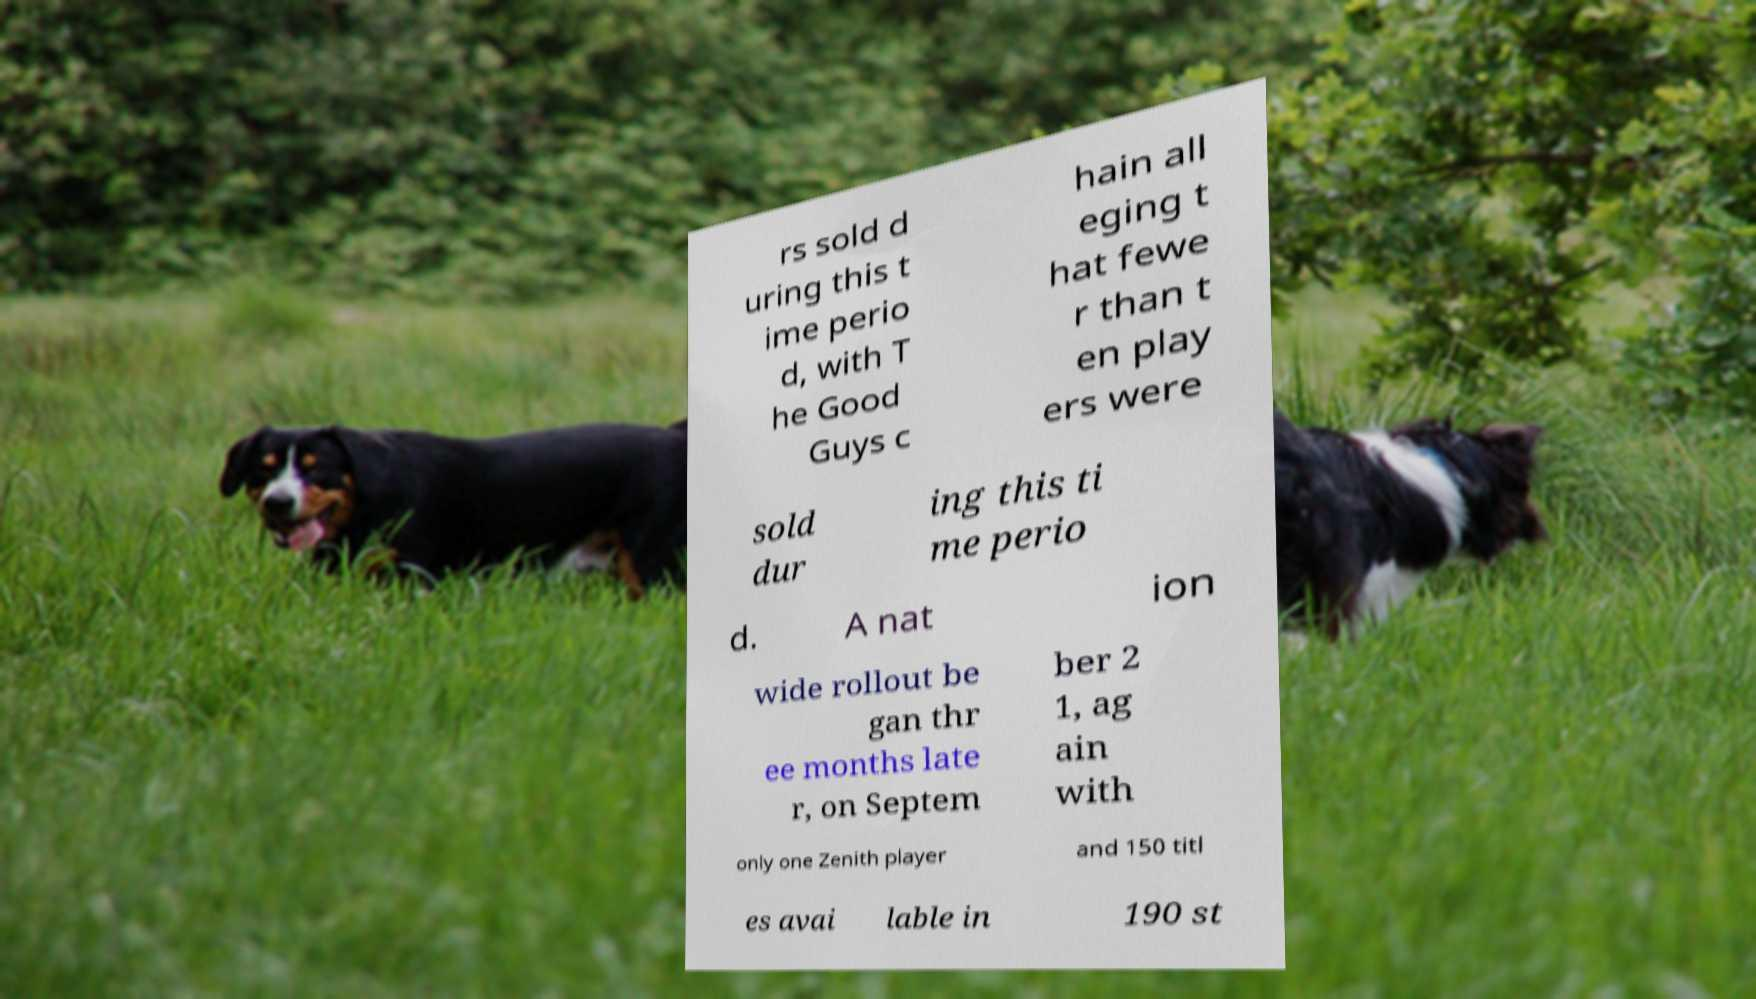Could you assist in decoding the text presented in this image and type it out clearly? rs sold d uring this t ime perio d, with T he Good Guys c hain all eging t hat fewe r than t en play ers were sold dur ing this ti me perio d. A nat ion wide rollout be gan thr ee months late r, on Septem ber 2 1, ag ain with only one Zenith player and 150 titl es avai lable in 190 st 